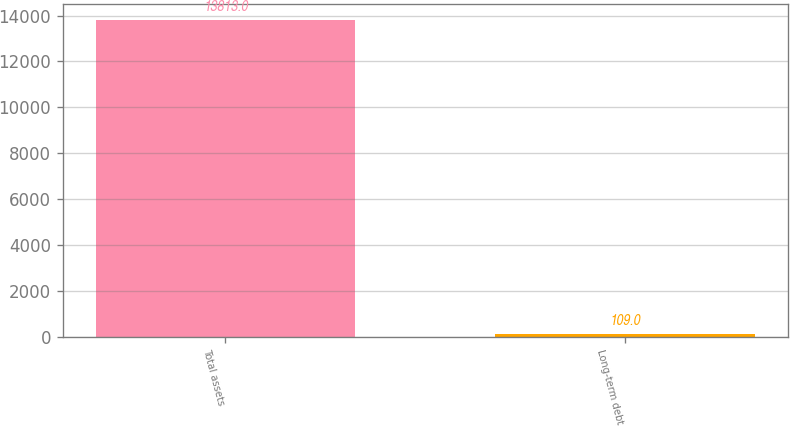Convert chart. <chart><loc_0><loc_0><loc_500><loc_500><bar_chart><fcel>Total assets<fcel>Long-term debt<nl><fcel>13813<fcel>109<nl></chart> 